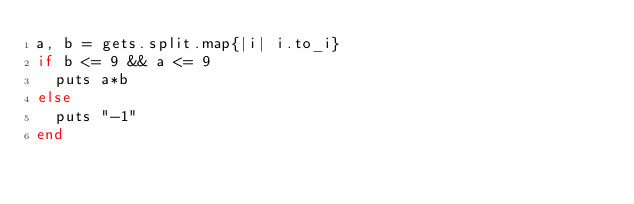<code> <loc_0><loc_0><loc_500><loc_500><_Ruby_>a, b = gets.split.map{|i| i.to_i}
if b <= 9 && a <= 9
  puts a*b
else
  puts "-1"
end</code> 